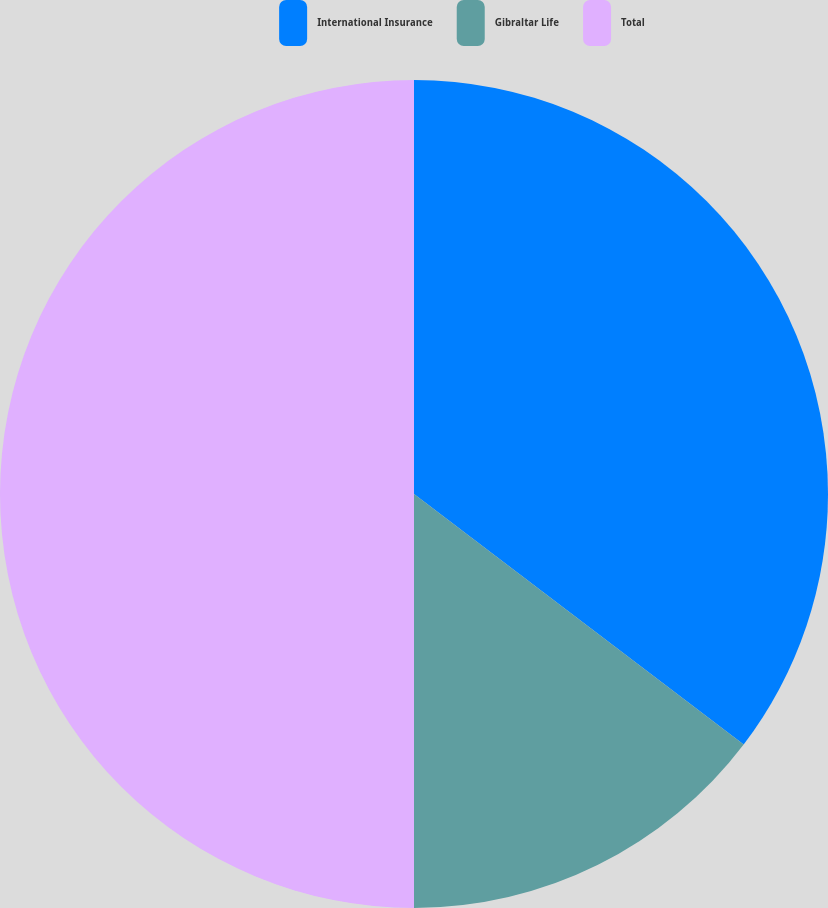Convert chart to OTSL. <chart><loc_0><loc_0><loc_500><loc_500><pie_chart><fcel>International Insurance<fcel>Gibraltar Life<fcel>Total<nl><fcel>35.34%<fcel>14.66%<fcel>50.0%<nl></chart> 